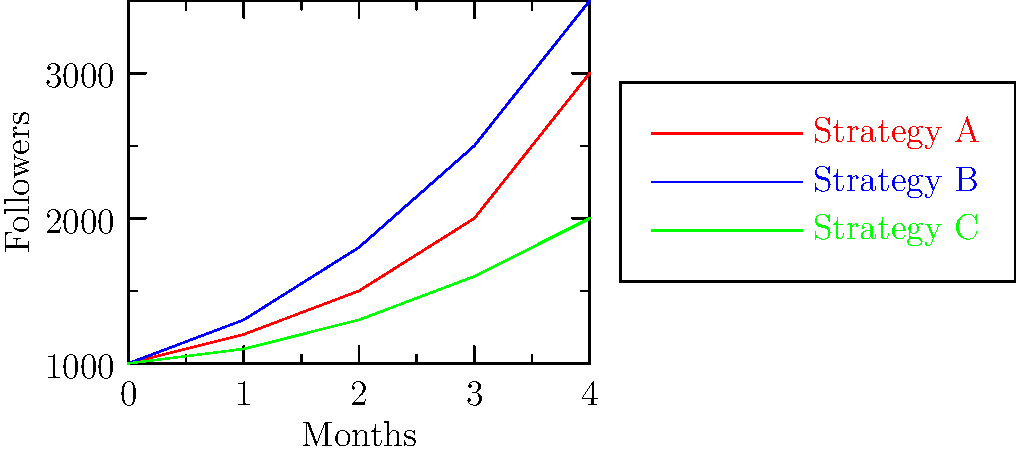As a tech conference speaker, you're presenting on social media growth strategies. The graph shows the follower growth over 4 months using three different engagement strategies. Which strategy shows the most consistent rate of growth, and how would you use this information to inspire your audience of software engineers to implement data-driven social media strategies? To determine the most consistent rate of growth and inspire the audience:

1. Analyze each strategy:
   Strategy A (red): Shows increasing growth rate
   Strategy B (blue): Exhibits the steepest overall growth
   Strategy C (green): Demonstrates the most consistent growth rate

2. Identify the most consistent:
   Strategy C (green) has the most uniform slope, indicating steady growth.

3. Calculate growth rates:
   Strategy C: (2000 - 1000) / 4 months = 250 followers/month

4. Inspire the audience:
   a) Emphasize the importance of data analysis in strategy selection
   b) Highlight how consistent growth (Strategy C) can be more predictable and manageable
   c) Discuss how software engineers can create tools to track and analyze social media metrics
   d) Encourage the audience to implement A/B testing for different strategies
   e) Suggest developing algorithms to optimize posting times and content types

5. Connect to software engineering:
   a) Propose creating dashboards for real-time strategy performance monitoring
   b) Discuss the potential of machine learning in predicting audience engagement
   c) Emphasize the value of data-driven decision making in social media management

By focusing on the consistent growth of Strategy C and relating it to software engineering principles, you can inspire the audience to apply their technical skills to social media strategy optimization.
Answer: Strategy C; Use data analysis to show consistent growth, encourage developing tools for tracking metrics, and implementing machine learning for engagement prediction. 